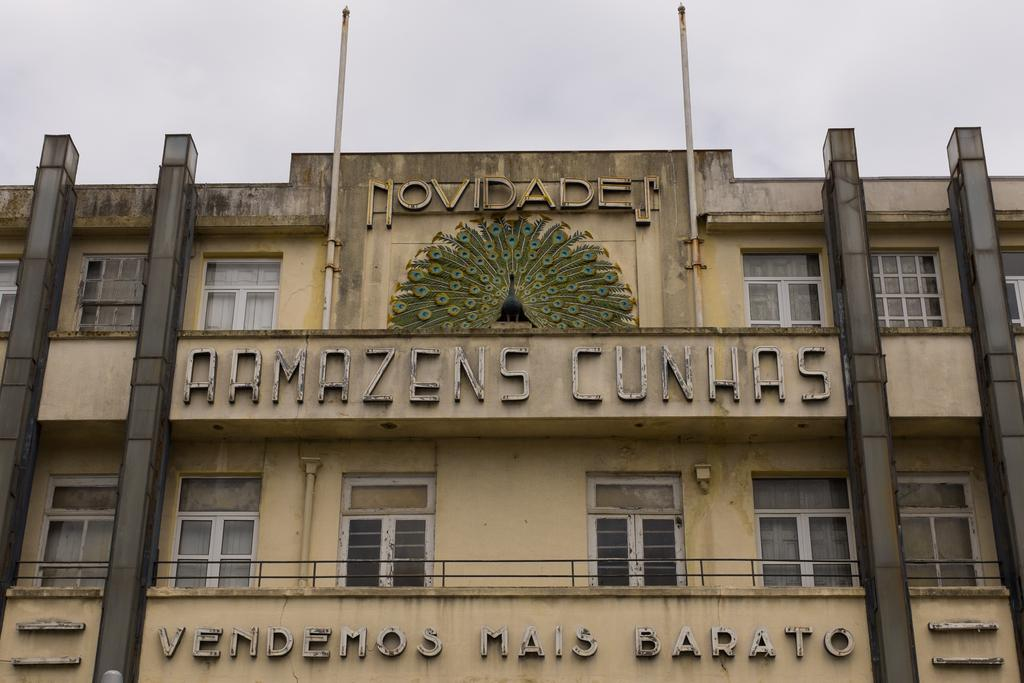What type of structure is present in the image? There is a building in the image. What architectural features can be seen on the building? The building has pillars and windows. What else is present in the image besides the building? There is a board, a wall painting, and a pole in the image. What can be seen in the background of the image? The sky is visible in the image, and it was likely taken during the day. How many buckets are being used for digestion in the image? There are no buckets or references to digestion in the image. Can you tell me how many mice are hiding behind the wall painting in the image? There are no mice present in the image; it only features a building, a board, a wall painting, and a pole. 